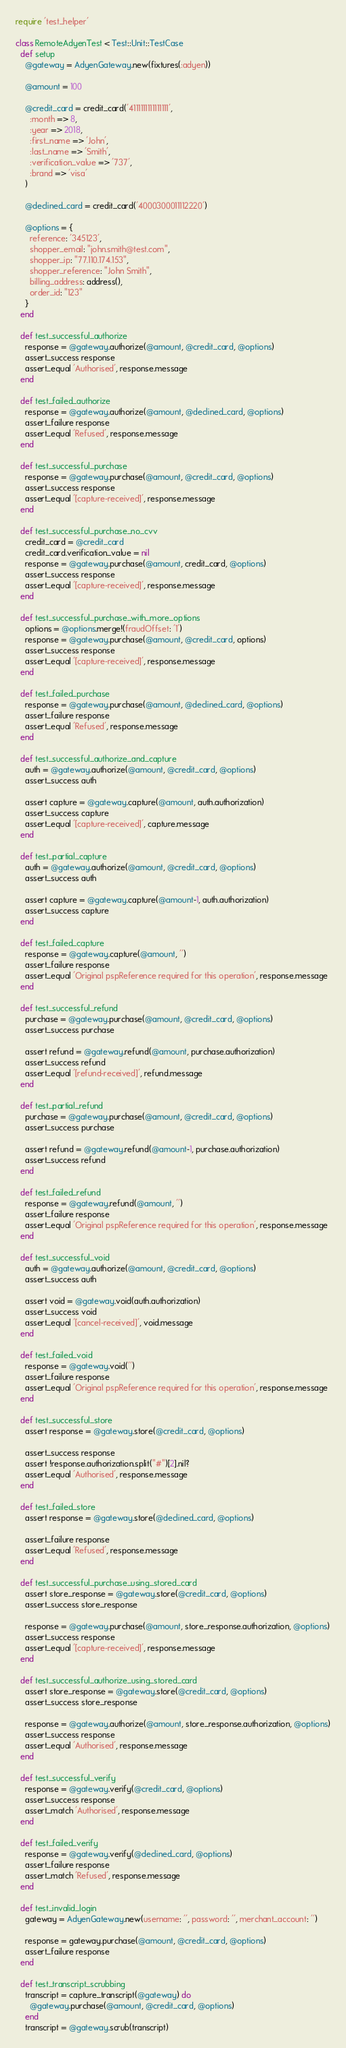<code> <loc_0><loc_0><loc_500><loc_500><_Ruby_>require 'test_helper'

class RemoteAdyenTest < Test::Unit::TestCase
  def setup
    @gateway = AdyenGateway.new(fixtures(:adyen))

    @amount = 100

    @credit_card = credit_card('4111111111111111',
      :month => 8,
      :year => 2018,
      :first_name => 'John',
      :last_name => 'Smith',
      :verification_value => '737',
      :brand => 'visa'
    )

    @declined_card = credit_card('4000300011112220')

    @options = {
      reference: '345123',
      shopper_email: "john.smith@test.com",
      shopper_ip: "77.110.174.153",
      shopper_reference: "John Smith",
      billing_address: address(),
      order_id: "123"
    }
  end

  def test_successful_authorize
    response = @gateway.authorize(@amount, @credit_card, @options)
    assert_success response
    assert_equal 'Authorised', response.message
  end

  def test_failed_authorize
    response = @gateway.authorize(@amount, @declined_card, @options)
    assert_failure response
    assert_equal 'Refused', response.message
  end

  def test_successful_purchase
    response = @gateway.purchase(@amount, @credit_card, @options)
    assert_success response
    assert_equal '[capture-received]', response.message
  end

  def test_successful_purchase_no_cvv
    credit_card = @credit_card
    credit_card.verification_value = nil
    response = @gateway.purchase(@amount, credit_card, @options)
    assert_success response
    assert_equal '[capture-received]', response.message
  end

  def test_successful_purchase_with_more_options
    options = @options.merge!(fraudOffset: '1')
    response = @gateway.purchase(@amount, @credit_card, options)
    assert_success response
    assert_equal '[capture-received]', response.message
  end

  def test_failed_purchase
    response = @gateway.purchase(@amount, @declined_card, @options)
    assert_failure response
    assert_equal 'Refused', response.message
  end

  def test_successful_authorize_and_capture
    auth = @gateway.authorize(@amount, @credit_card, @options)
    assert_success auth

    assert capture = @gateway.capture(@amount, auth.authorization)
    assert_success capture
    assert_equal '[capture-received]', capture.message
  end

  def test_partial_capture
    auth = @gateway.authorize(@amount, @credit_card, @options)
    assert_success auth

    assert capture = @gateway.capture(@amount-1, auth.authorization)
    assert_success capture
  end

  def test_failed_capture
    response = @gateway.capture(@amount, '')
    assert_failure response
    assert_equal 'Original pspReference required for this operation', response.message
  end

  def test_successful_refund
    purchase = @gateway.purchase(@amount, @credit_card, @options)
    assert_success purchase

    assert refund = @gateway.refund(@amount, purchase.authorization)
    assert_success refund
    assert_equal '[refund-received]', refund.message
  end

  def test_partial_refund
    purchase = @gateway.purchase(@amount, @credit_card, @options)
    assert_success purchase

    assert refund = @gateway.refund(@amount-1, purchase.authorization)
    assert_success refund
  end

  def test_failed_refund
    response = @gateway.refund(@amount, '')
    assert_failure response
    assert_equal 'Original pspReference required for this operation', response.message
  end

  def test_successful_void
    auth = @gateway.authorize(@amount, @credit_card, @options)
    assert_success auth

    assert void = @gateway.void(auth.authorization)
    assert_success void
    assert_equal '[cancel-received]', void.message
  end

  def test_failed_void
    response = @gateway.void('')
    assert_failure response
    assert_equal 'Original pspReference required for this operation', response.message
  end

  def test_successful_store
    assert response = @gateway.store(@credit_card, @options)

    assert_success response
    assert !response.authorization.split("#")[2].nil?
    assert_equal 'Authorised', response.message
  end

  def test_failed_store
    assert response = @gateway.store(@declined_card, @options)

    assert_failure response
    assert_equal 'Refused', response.message
  end

  def test_successful_purchase_using_stored_card
    assert store_response = @gateway.store(@credit_card, @options)
    assert_success store_response

    response = @gateway.purchase(@amount, store_response.authorization, @options)
    assert_success response
    assert_equal '[capture-received]', response.message
  end

  def test_successful_authorize_using_stored_card
    assert store_response = @gateway.store(@credit_card, @options)
    assert_success store_response

    response = @gateway.authorize(@amount, store_response.authorization, @options)
    assert_success response
    assert_equal 'Authorised', response.message
  end

  def test_successful_verify
    response = @gateway.verify(@credit_card, @options)
    assert_success response
    assert_match 'Authorised', response.message
  end

  def test_failed_verify
    response = @gateway.verify(@declined_card, @options)
    assert_failure response
    assert_match 'Refused', response.message
  end

  def test_invalid_login
    gateway = AdyenGateway.new(username: '', password: '', merchant_account: '')

    response = gateway.purchase(@amount, @credit_card, @options)
    assert_failure response
  end

  def test_transcript_scrubbing
    transcript = capture_transcript(@gateway) do
      @gateway.purchase(@amount, @credit_card, @options)
    end
    transcript = @gateway.scrub(transcript)
</code> 